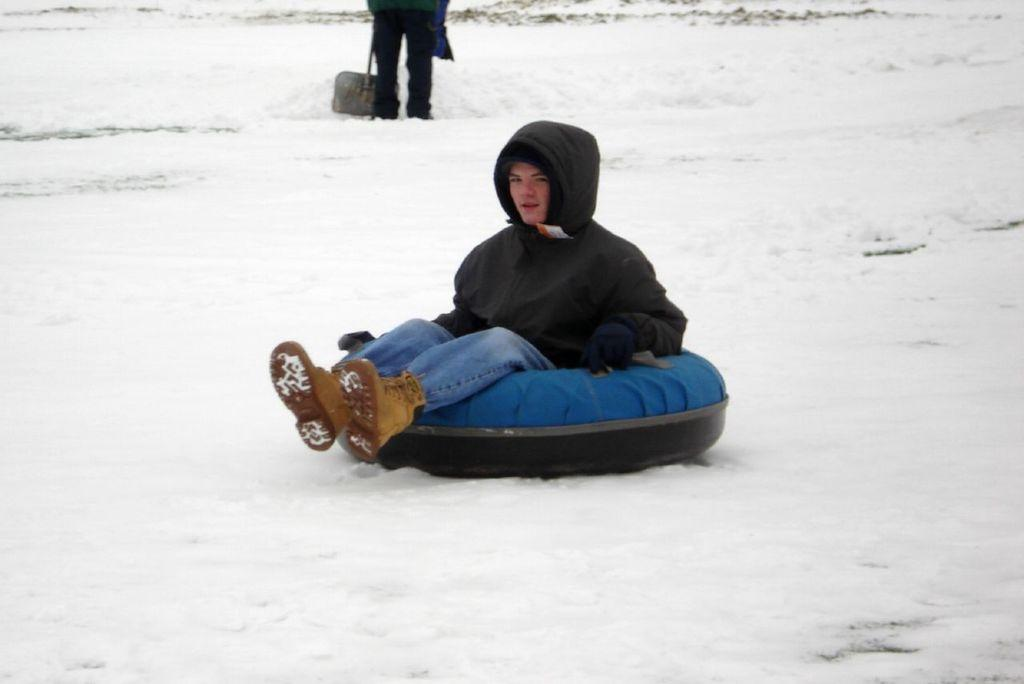What is the person in the image wearing? The person in the image is wearing clothes. What is the person sitting on in the image? The person is sitting on a tube. How many people are in the image? There are two people in the image. Can you describe the second person in the image? The second person's face is not visible, and they are standing at the top of the image. What type of van is visible in the image? There is no van present in the image. How does the light affect the image? The image does not mention any specific lighting conditions, so it is not possible to determine how light affects the image. 